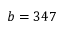<formula> <loc_0><loc_0><loc_500><loc_500>b = 3 4 7</formula> 